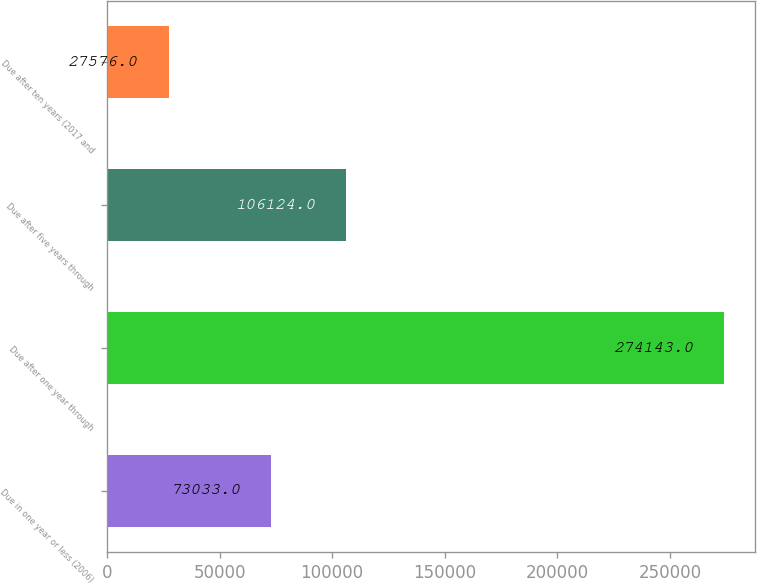<chart> <loc_0><loc_0><loc_500><loc_500><bar_chart><fcel>Due in one year or less (2006)<fcel>Due after one year through<fcel>Due after five years through<fcel>Due after ten years (2017 and<nl><fcel>73033<fcel>274143<fcel>106124<fcel>27576<nl></chart> 